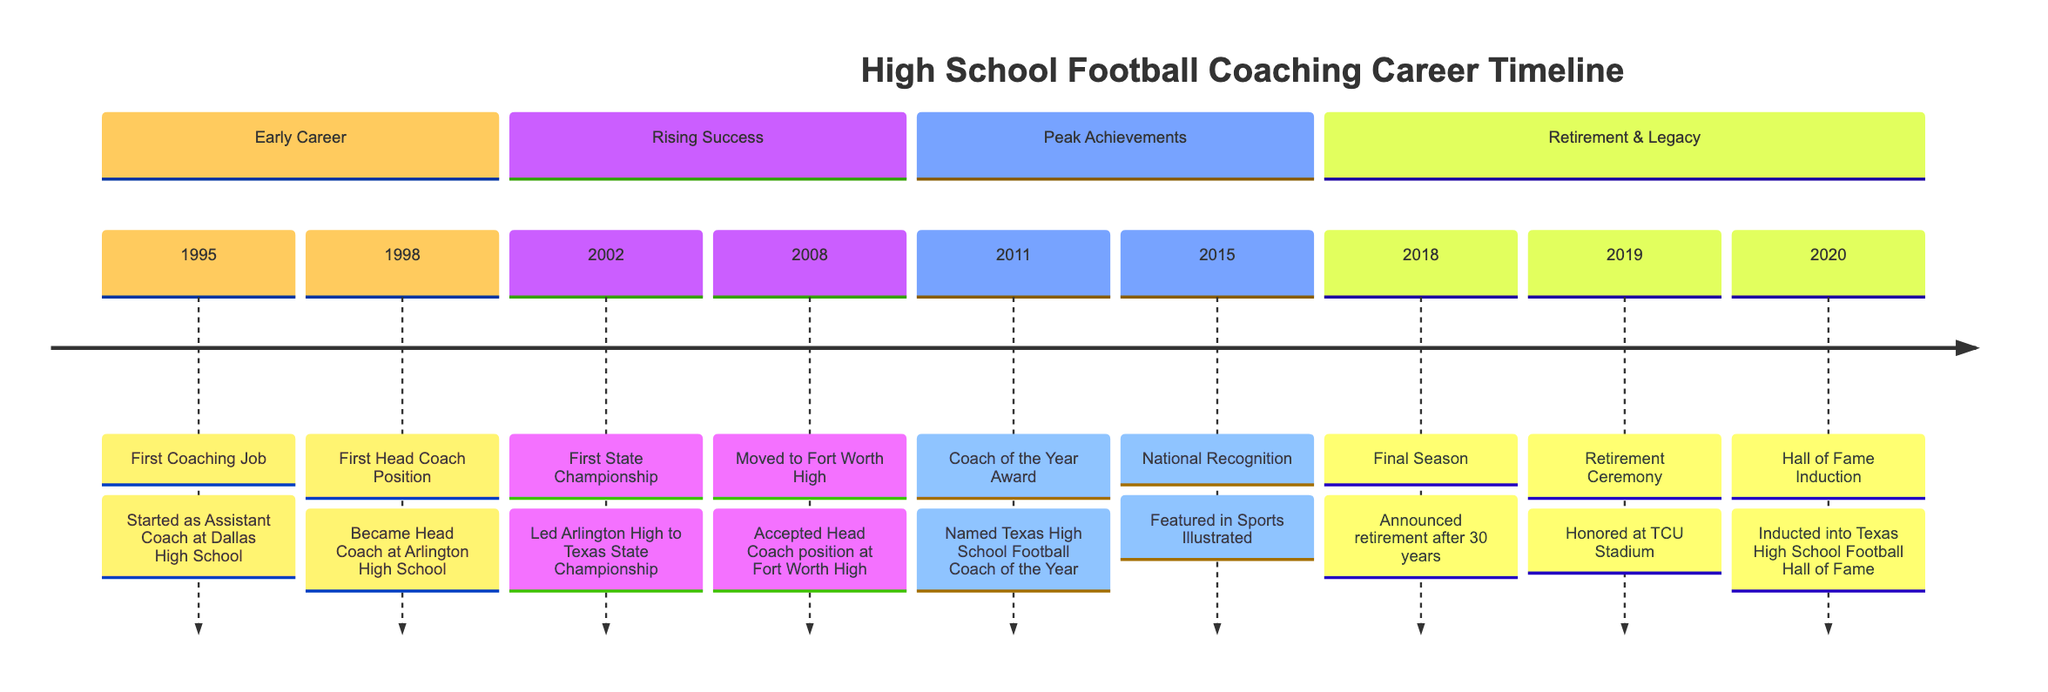What year did the first coaching job occur? The timeline starts in 1995, where the first coaching job is recorded as occurring. This is explicitly stated in the event for that year.
Answer: 1995 How many different coaching positions are listed on the timeline? The timeline shows four distinct coaching positions: Assistant Coach at Dallas High School, Head Coach at Arlington High School, Head Coach at Fort Worth High School, and the recognition received over the years. Counting these positions gives a total of four.
Answer: 4 What significant award did the coach receive in 2011? In 2011, the timeline indicates that the coach received the Texas High School Football Coach of the Year Award. This is specifically mentioned as a notable event in that year.
Answer: Coach of the Year Award What event occurred in 2019? The timeline states that in 2019, a retirement ceremony was held at the TCU Stadium. This detail is provided directly under the year 2019 in the timeline.
Answer: Retirement Ceremony Which high school did the coach start their head coaching career? The timeline notes that the coach became the Head Coach at Arlington High School in 1998. This is clearly indicated as their first head coaching position.
Answer: Arlington High School What achievement is associated with the year 2002? The event for the year 2002 on the timeline details that the coach led the Arlington High School team to victory in the Texas State Championship, marking a significant accomplishment early in their career.
Answer: First State Championship In which year did the coach announce their retirement? The timeline indicates that the coach announced retirement in 2018, providing a clear point for when this life change was made, as denoted in the events of that year.
Answer: 2018 What type of recognition did the coach receive in 2015? In 2015, the timeline describes a national recognition where the coach was featured in Sports Illustrated, suggesting notable achievements that gained broader visibility.
Answer: National Recognition How many years did the coach spend in their career before retiring? The timeline notes a 30-year career, concluding with the announcement of retirement in 2018. This detail allows for a straightforward calculation of the career duration.
Answer: 30 years 